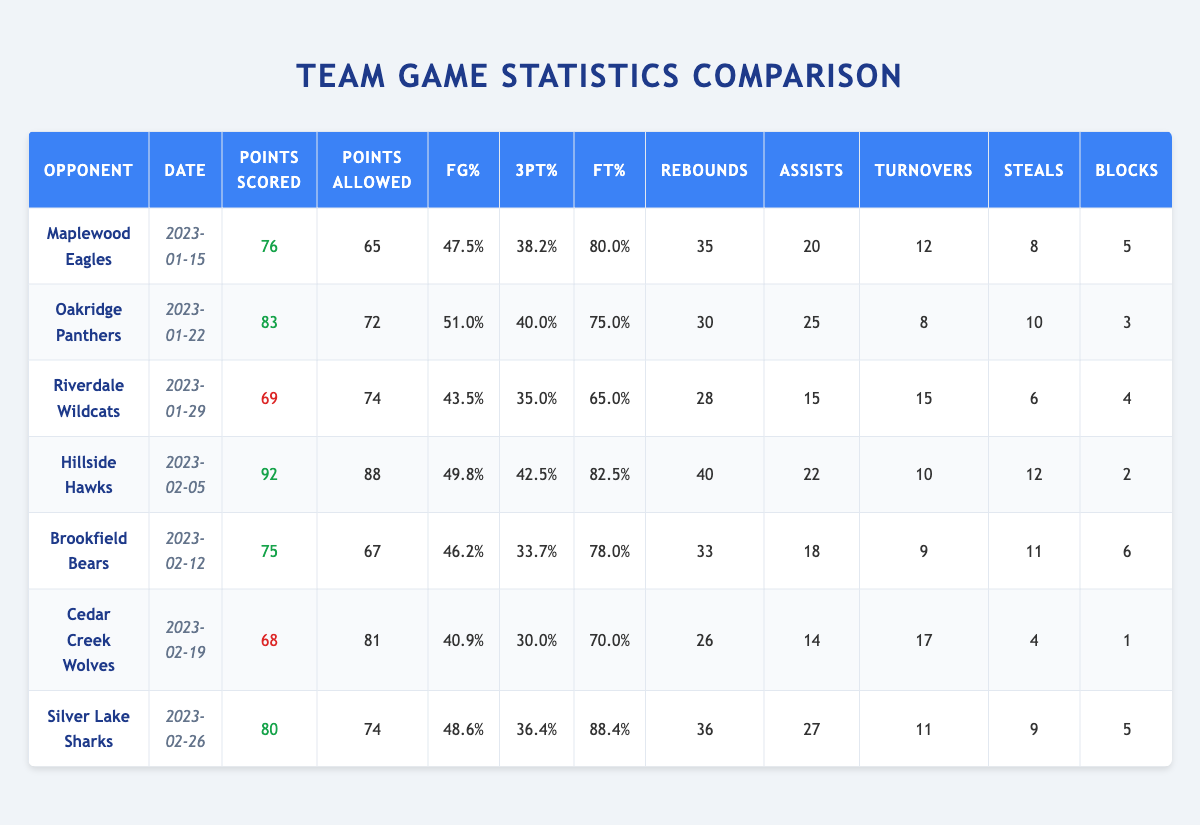What was the highest points scored by the team in a single game? Looking through the points scored column, the highest value is 92 against Hillside Hawks on February 5, 2023.
Answer: 92 Against which opponent did the team allow the most points? The highest points allowed by the team is 88 points against Hillside Hawks on February 5, 2023.
Answer: Hillside Hawks What is the team's average field goal percentage across all games? To find the average, add all the field goal percentages: (47.5 + 51.0 + 43.5 + 49.8 + 46.2 + 40.9 + 48.6) = 378.5. There are 7 games, so the average is 378.5 / 7 = 54.07%.
Answer: 54.07% How many total rebounds did the team get across all games? Adding the rebounds together: 35 + 30 + 28 + 40 + 33 + 26 + 36 = 238.
Answer: 238 What was the team's free throw percentage in the game against Silver Lake Sharks? The table shows the free throw percentage against Silver Lake Sharks on February 26, 2023, is 88.4%.
Answer: 88.4% In how many games did the team have more assists than turnovers? Looking at each game, they had more assists than turnovers in games against Maplewood Eagles, Oakridge Panthers, Hillside Hawks, Brookfield Bears, and Silver Lake Sharks (5 total).
Answer: 5 Did the team win against Riverdale Wildcats? The points scored (69) were less than points allowed (74), indicating a loss to Riverdale Wildcats on January 29, 2023.
Answer: No What is the difference in points scored and points allowed in the game against Oakridge Panthers? The points scored is 83 and points allowed is 72, so the difference is 83 - 72 = 11.
Answer: 11 Which opponent had the highest field goal percentage allowed by the team? The points allowed are highest against Hillside Hawks with a field goal percentage of 49.8%.
Answer: Hillside Hawks What is the overall win-loss record based on the points scored and allowed? The team won against Maplewood Eagles, Oakridge Panthers, Hillside Hawks, Brookfield Bears, and Silver Lake Sharks, while losing to Riverdale Wildcats and Cedar Creek Wolves, resulting in a 5-2 record.
Answer: 5-2 